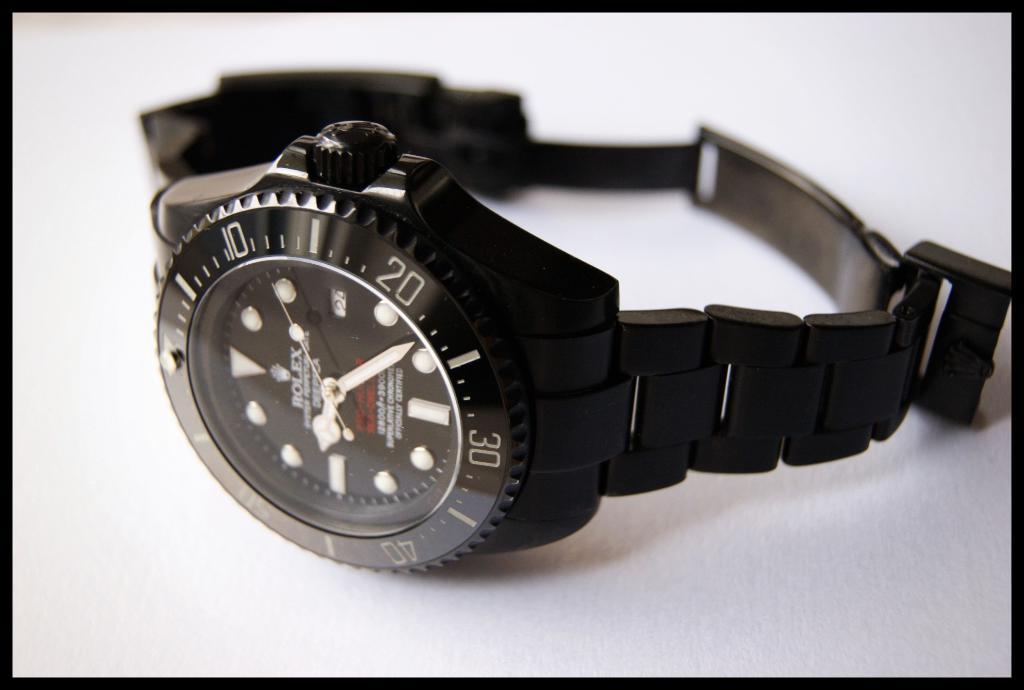What brand of watch is this?
Your response must be concise. Rolex. What time is it?
Offer a terse response. 9:23. 